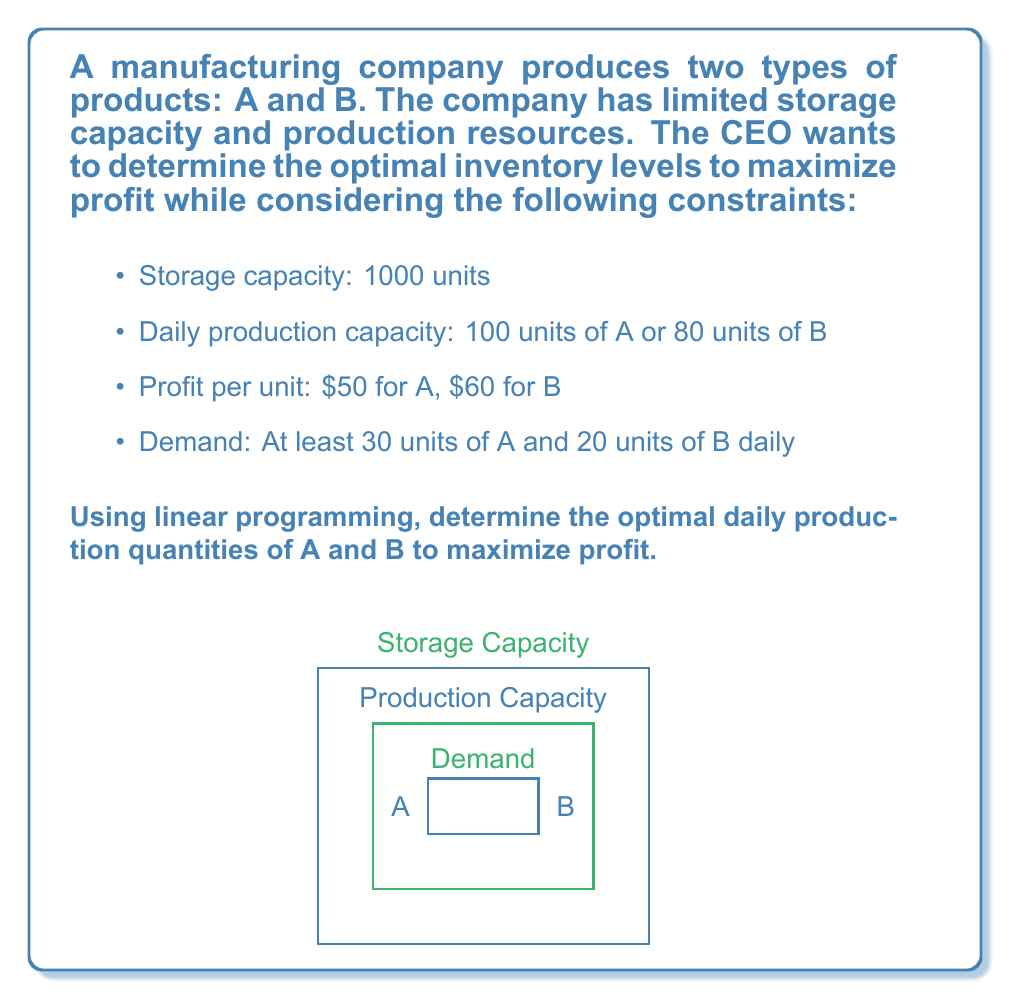Can you answer this question? Let's solve this problem using linear programming:

1) Define variables:
   Let $x$ be the number of units of A
   Let $y$ be the number of units of B

2) Objective function (maximize profit):
   $$ \text{Maximize } Z = 50x + 60y $$

3) Constraints:
   a) Storage capacity: $x + y \leq 1000$
   b) Production capacity: $\frac{x}{100} + \frac{y}{80} \leq 1$
   c) Demand for A: $x \geq 30$
   d) Demand for B: $y \geq 20$
   e) Non-negativity: $x \geq 0, y \geq 0$

4) Simplify production capacity constraint:
   $\frac{x}{100} + \frac{y}{80} \leq 1$
   $4x + 5y \leq 400$

5) Graph the constraints and identify the feasible region.

6) Find the corner points of the feasible region:
   - (30, 20)
   - (30, 76)
   - (70, 66)
   - (100, 0)

7) Evaluate the objective function at each corner point:
   - Z(30, 20) = 50(30) + 60(20) = 2700
   - Z(30, 76) = 50(30) + 60(76) = 6060
   - Z(70, 66) = 50(70) + 60(66) = 7460
   - Z(100, 0) = 50(100) + 60(0) = 5000

8) The maximum profit occurs at the point (70, 66).

Therefore, the optimal daily production quantities are 70 units of A and 66 units of B.
Answer: 70 units of A, 66 units of B 